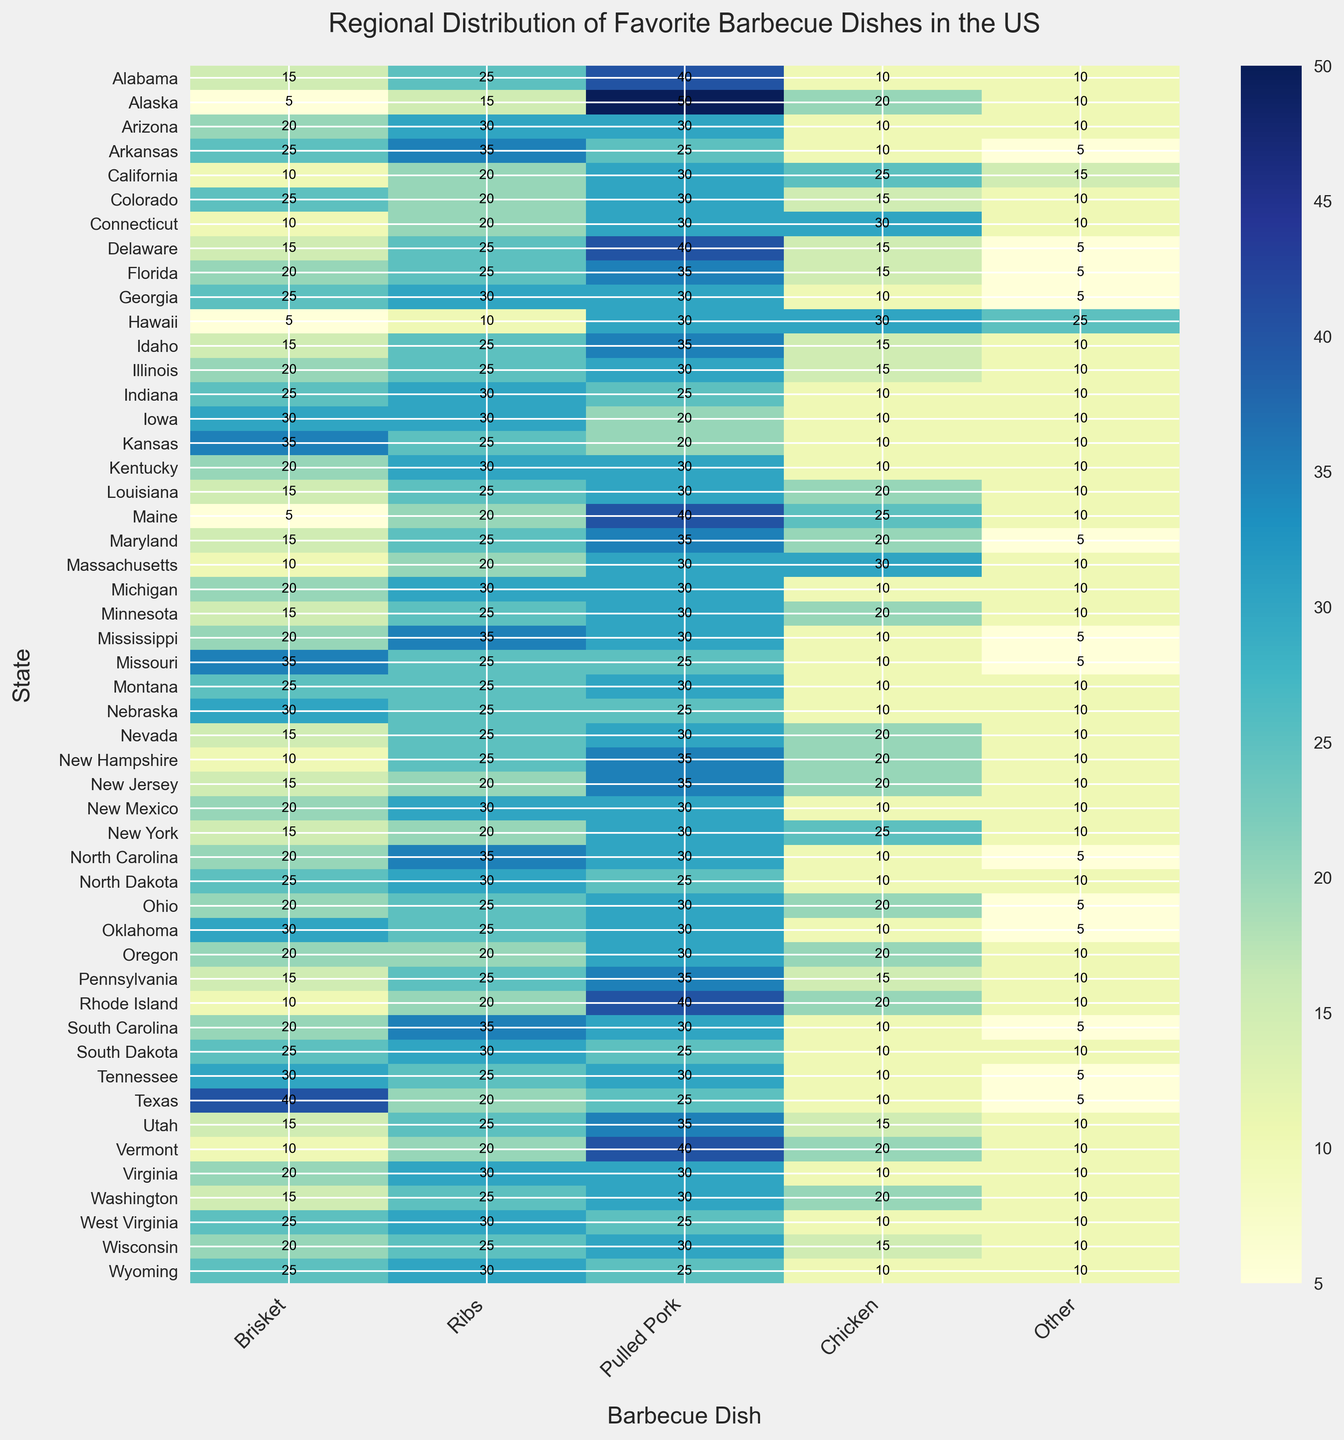Which state has the highest preference for pulled pork? By looking at the column for 'Pulled Pork', identify the cell with the highest numerical value. Alaska has the highest value of 50.
Answer: Alaska What is the most popular barbecue dish in Iowa? Locate Iowa on the y-axis and find the highest value in its row. The 'Brisket' column has the highest value of 30.
Answer: Brisket Which state has a higher preference for ribs: Texas or California? Compare the values in the 'Ribs' column for Texas and California. Texas has 20 and California has 20.
Answer: Equal How many states have pulled pork as their most preferred barbecue dish? Count the number of rows where the 'Pulled Pork' column has the highest value in that row.
Answer: 20 states What is the sum of preferences for brisket and chicken in Montana? For Montana, add the values in the 'Brisket' and 'Chicken' columns: 25 (Brisket) + 10 (Chicken) = 35.
Answer: 35 Which category has the least preference overall in the dataset? Sum the columns and find the one with the smallest total. 'Other' has the smallest total.
Answer: Other Is chicken or ribs more popular in Georgia? Compare the values for 'Chicken' and 'Ribs' in Georgia's row. 'Ribs' has 30 and 'Chicken' has 10.
Answer: Ribs What is the average preference for chicken across all states? Sum the 'Chicken' column and divide by the number of states (50). Sum = 815, so 815 / 50 = 16.3.
Answer: 16.3 How many states have equal preferences for brisket and ribs? Count the rows where the values in 'Brisket' are the same as in 'Ribs'.
Answer: 0 states Which state has the lowest preference for brisket? Identify the cell with the lowest numerical value in the 'Brisket' column. Hawaii has a value of 5.
Answer: Hawaii 